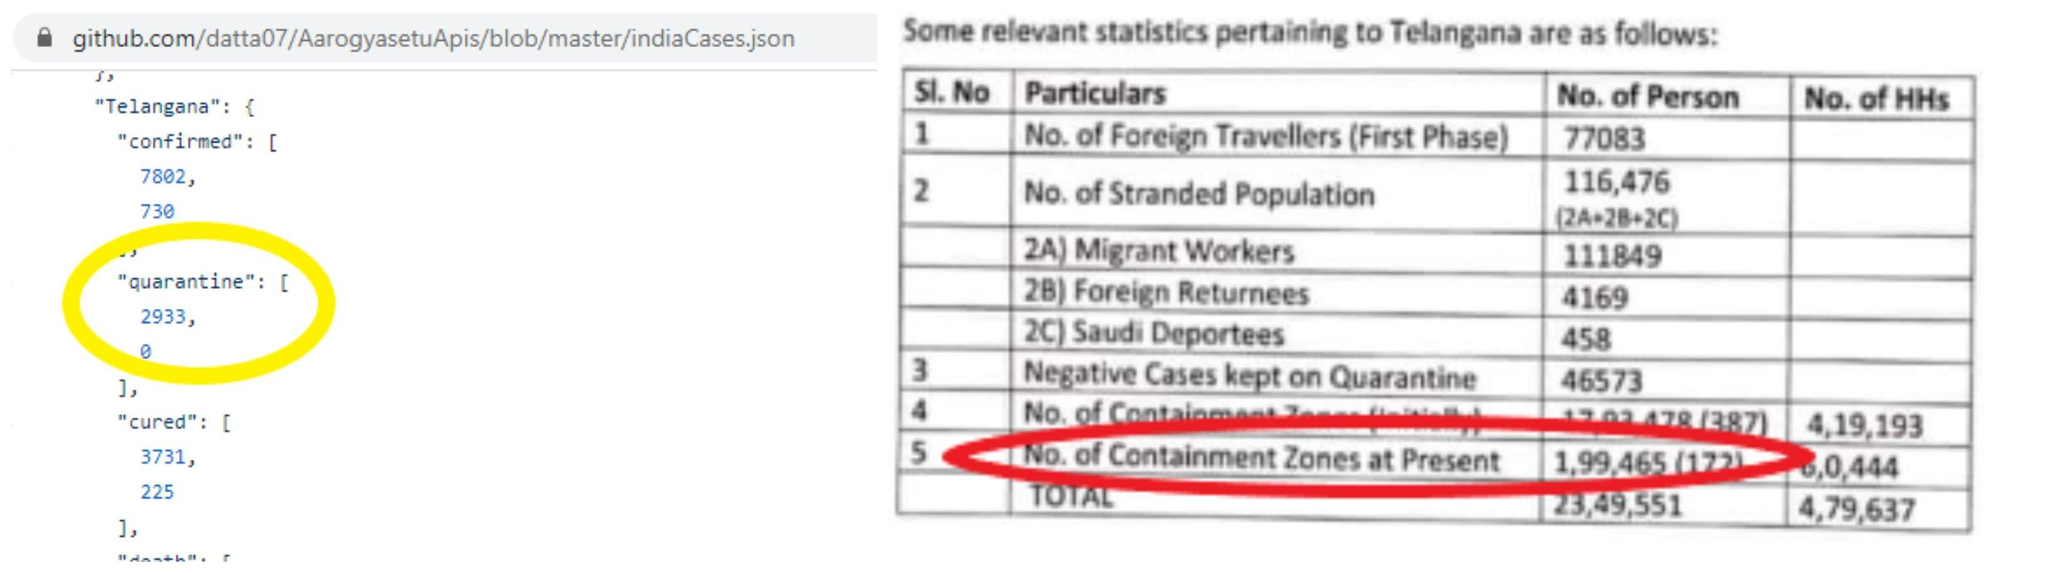Outline some significant characteristics in this image. The migrant workers have the highest number in the stranded population. 